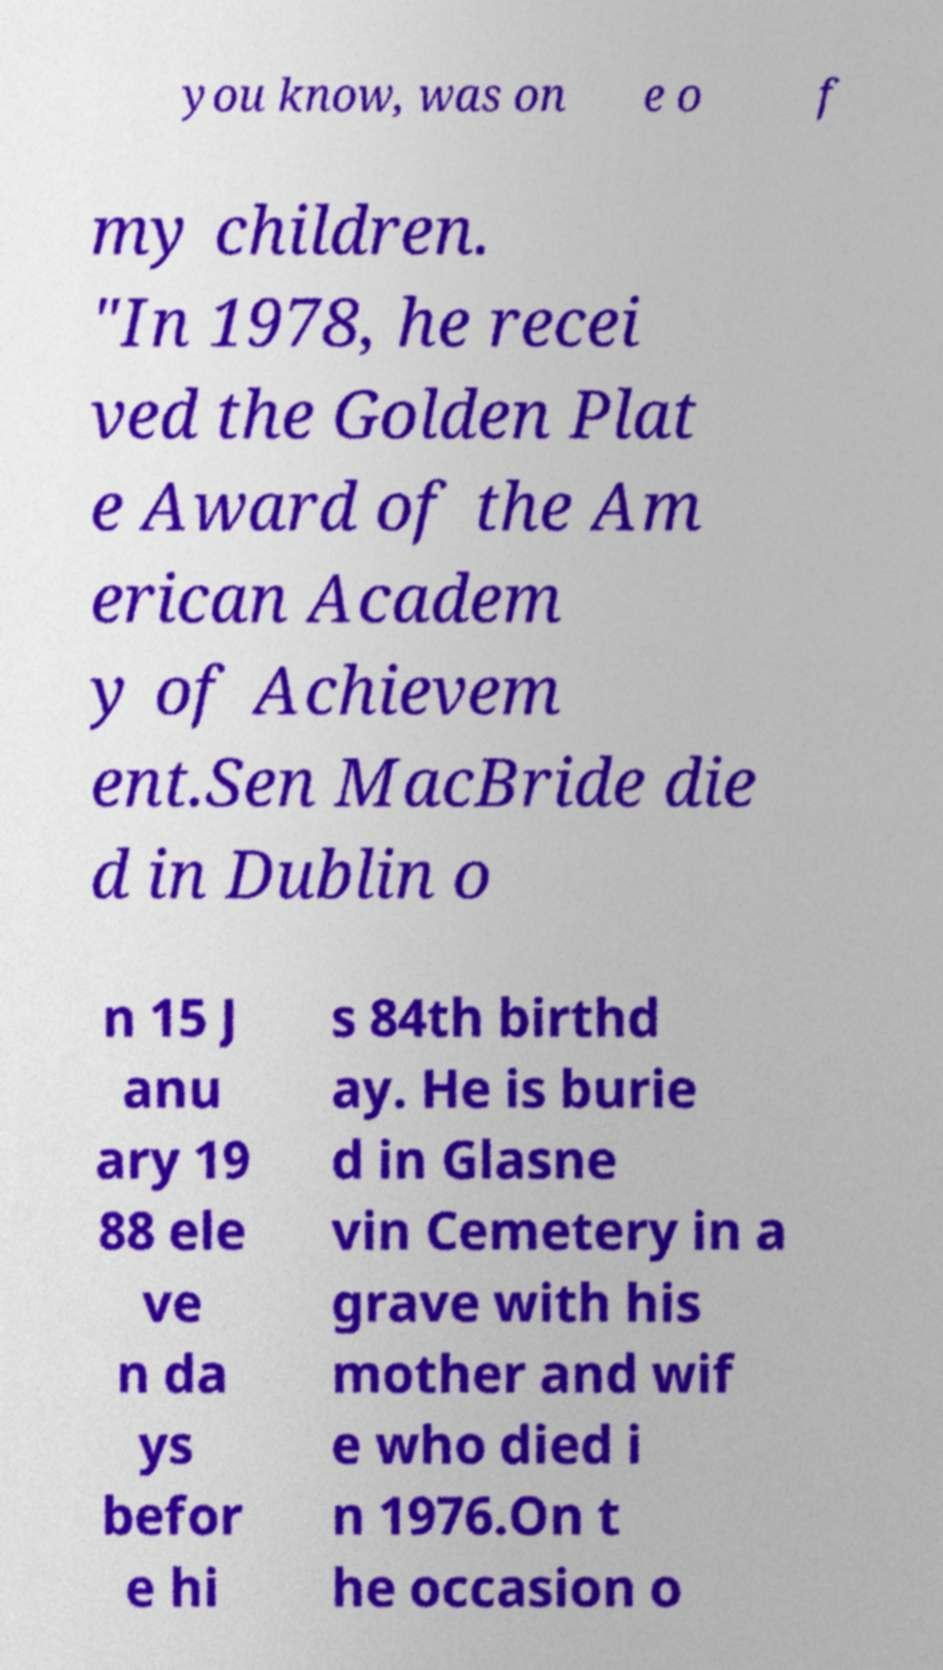What messages or text are displayed in this image? I need them in a readable, typed format. you know, was on e o f my children. "In 1978, he recei ved the Golden Plat e Award of the Am erican Academ y of Achievem ent.Sen MacBride die d in Dublin o n 15 J anu ary 19 88 ele ve n da ys befor e hi s 84th birthd ay. He is burie d in Glasne vin Cemetery in a grave with his mother and wif e who died i n 1976.On t he occasion o 